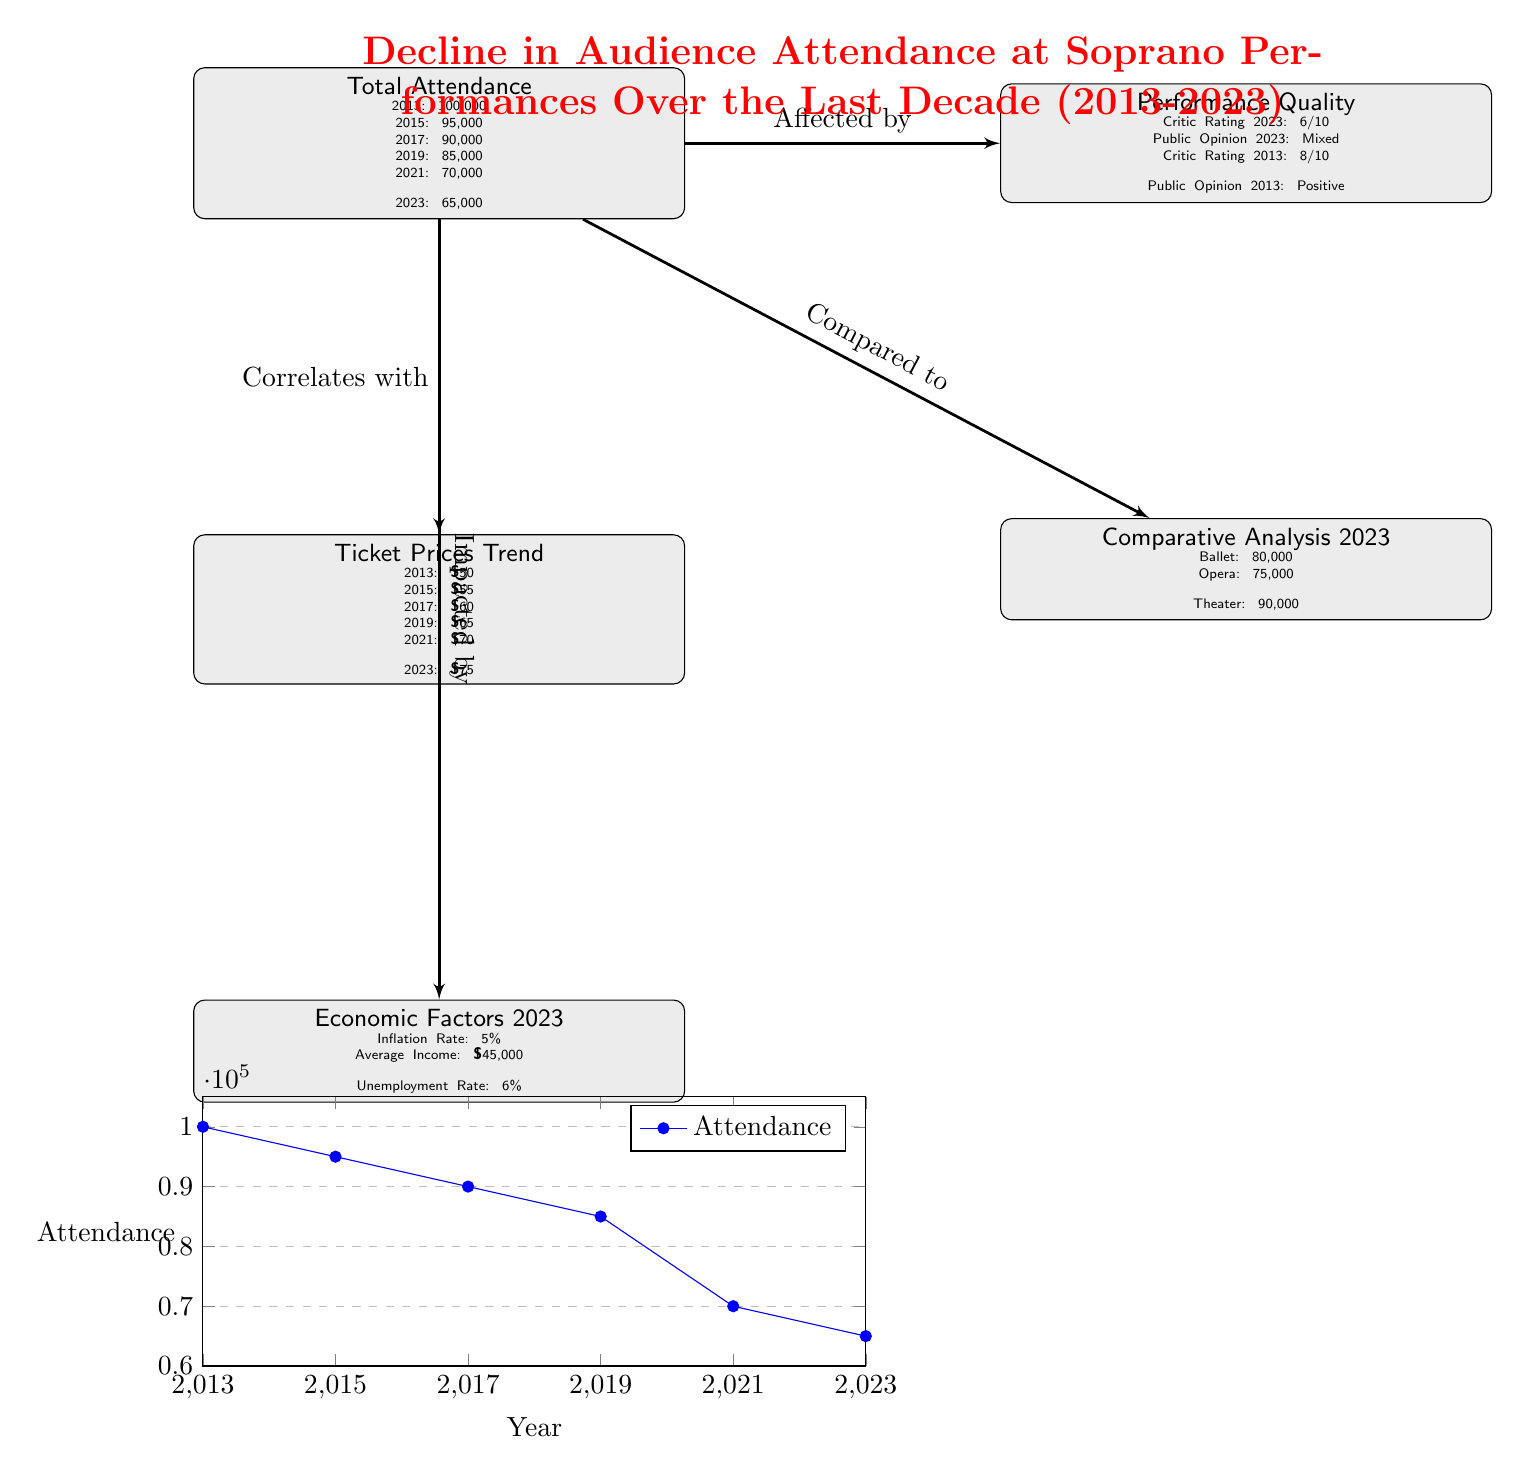What is the total attendance in 2013? The attendance node shows "Total Attendance" with 2013 specifically listed as 100,000.
Answer: 100,000 What is the ticket price in 2023? The ticket prices trend node indicates that the price in 2023 is listed as $75.
Answer: $75 What was the trend in attendance from 2013 to 2021? By reviewing the attendance data nodes, it shows a decline from 100,000 in 2013 to 70,000 in 2021, indicating a decrease.
Answer: Decrease How does the performance quality in 2023 compare to 2013? The performance quality node indicates a critic rating of 6/10 in 2023 and 8/10 in 2013, showing a drop in performance quality.
Answer: Drop Which type of performance has the highest comparative attendance in 2023? The comparative analysis node specifies ballet has 80,000 attendees, more than opera and theater, which have 75,000 and 90,000, respectively.
Answer: Ballet What economic factors were listed in 2023? The economic factors node provides the inflation rate, average income, and unemployment rate, specifically listing "Inflation Rate: 5%, Average Income: $45,000, Unemployment Rate: 6%."
Answer: Inflation Rate: 5%, Average Income: $45,000, Unemployment Rate: 6% How many edges are present in the diagram? By counting each connection drawn in the diagram, there are 4 edges connecting various nodes about attendance and influencing factors.
Answer: 4 What was the public opinion of soprano performances in 2023? The performance quality node notes that public opinion in 2023 is described as "Mixed."
Answer: Mixed What was the attendance in 2021? The attendance node shows that the total attendance listed for 2021 is 70,000.
Answer: 70,000 